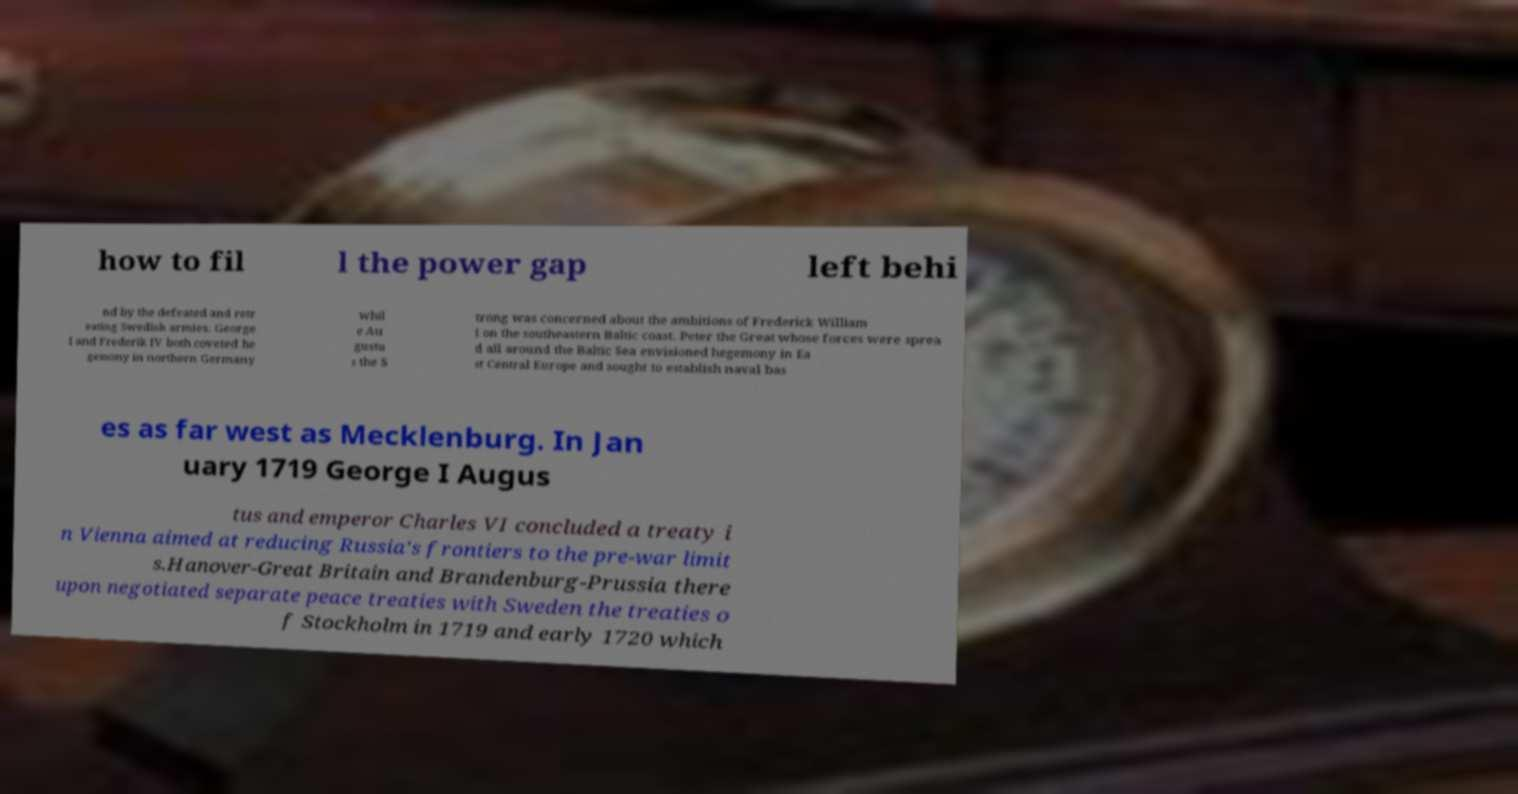Can you read and provide the text displayed in the image?This photo seems to have some interesting text. Can you extract and type it out for me? how to fil l the power gap left behi nd by the defeated and retr eating Swedish armies. George I and Frederik IV both coveted he gemony in northern Germany whil e Au gustu s the S trong was concerned about the ambitions of Frederick William I on the southeastern Baltic coast. Peter the Great whose forces were sprea d all around the Baltic Sea envisioned hegemony in Ea st Central Europe and sought to establish naval bas es as far west as Mecklenburg. In Jan uary 1719 George I Augus tus and emperor Charles VI concluded a treaty i n Vienna aimed at reducing Russia's frontiers to the pre-war limit s.Hanover-Great Britain and Brandenburg-Prussia there upon negotiated separate peace treaties with Sweden the treaties o f Stockholm in 1719 and early 1720 which 